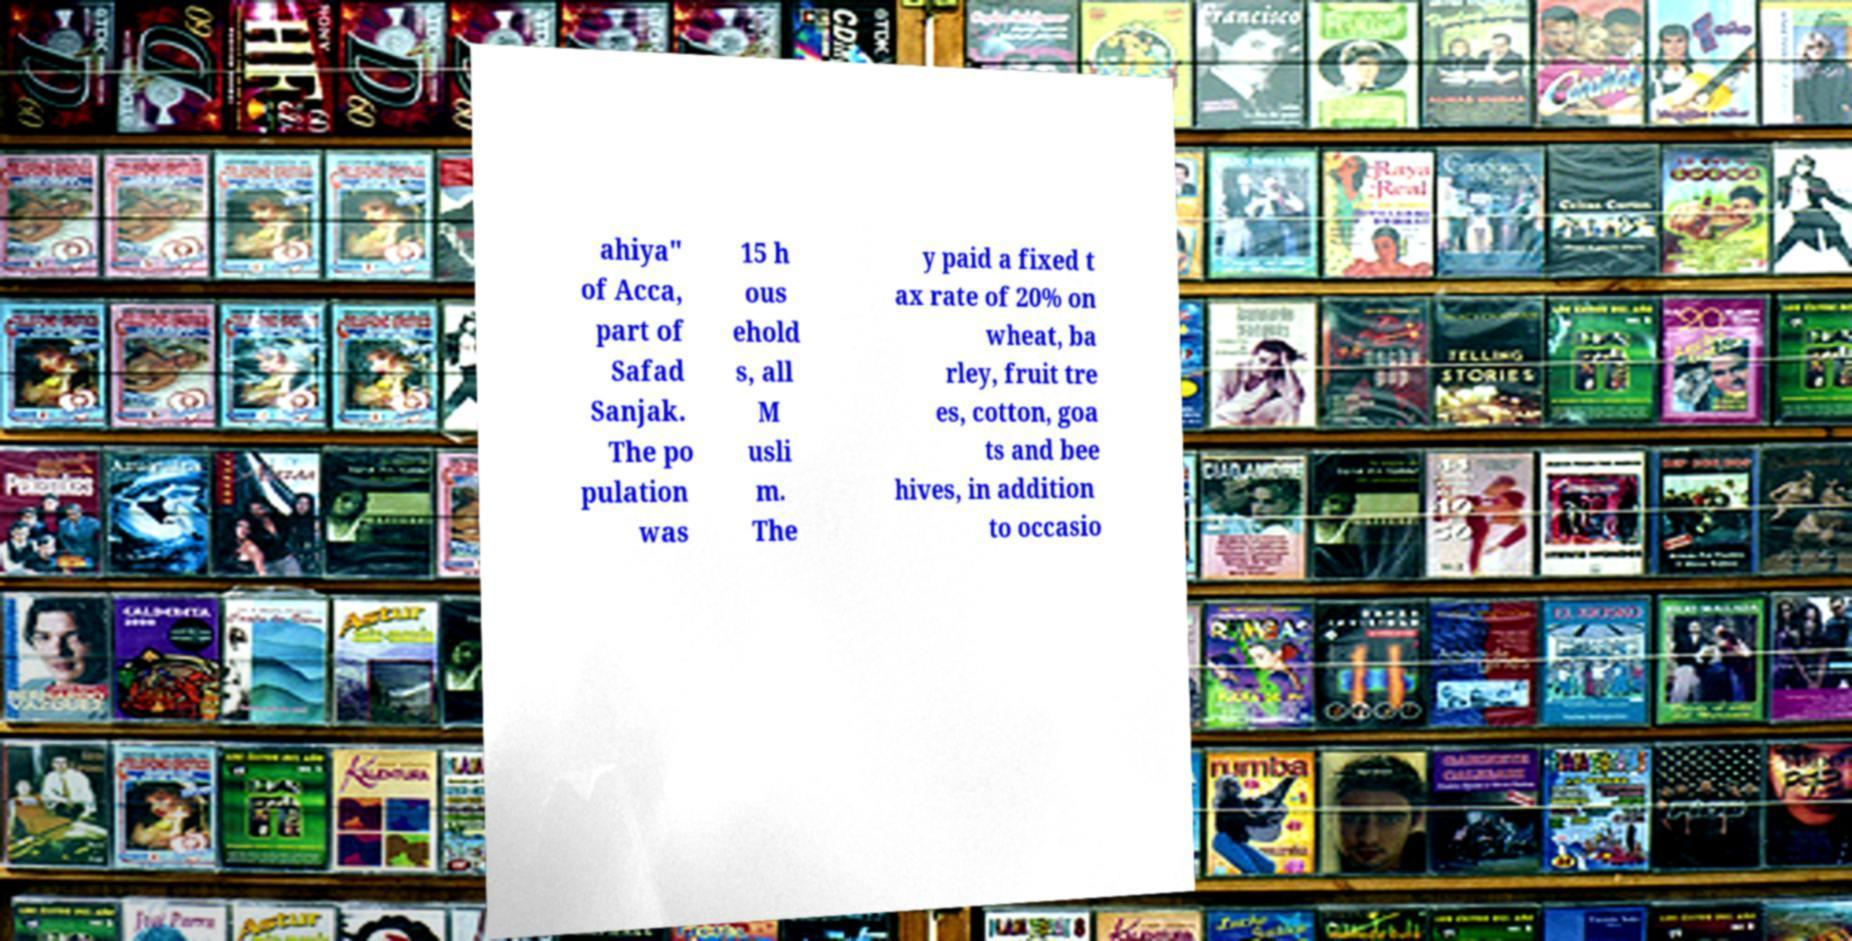What messages or text are displayed in this image? I need them in a readable, typed format. ahiya" of Acca, part of Safad Sanjak. The po pulation was 15 h ous ehold s, all M usli m. The y paid a fixed t ax rate of 20% on wheat, ba rley, fruit tre es, cotton, goa ts and bee hives, in addition to occasio 